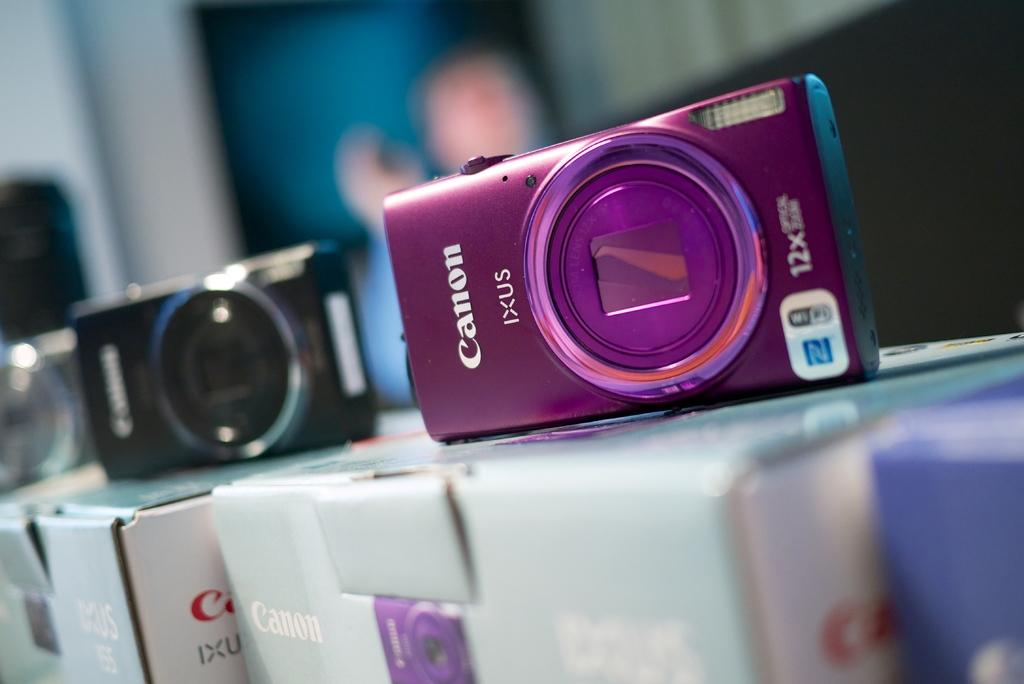<image>
Offer a succinct explanation of the picture presented. A black and magenta Canon Ixus digital cameras on top of their boxes. 